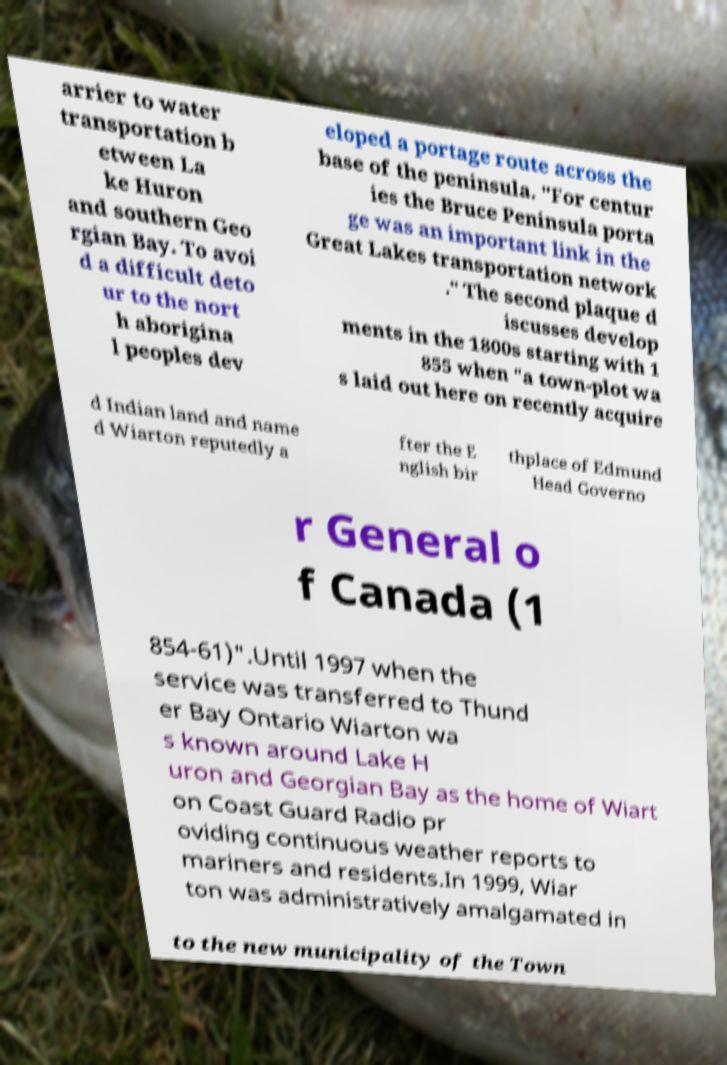Can you read and provide the text displayed in the image?This photo seems to have some interesting text. Can you extract and type it out for me? arrier to water transportation b etween La ke Huron and southern Geo rgian Bay. To avoi d a difficult deto ur to the nort h aborigina l peoples dev eloped a portage route across the base of the peninsula. "For centur ies the Bruce Peninsula porta ge was an important link in the Great Lakes transportation network ." The second plaque d iscusses develop ments in the 1800s starting with 1 855 when "a town-plot wa s laid out here on recently acquire d Indian land and name d Wiarton reputedly a fter the E nglish bir thplace of Edmund Head Governo r General o f Canada (1 854-61)".Until 1997 when the service was transferred to Thund er Bay Ontario Wiarton wa s known around Lake H uron and Georgian Bay as the home of Wiart on Coast Guard Radio pr oviding continuous weather reports to mariners and residents.In 1999, Wiar ton was administratively amalgamated in to the new municipality of the Town 